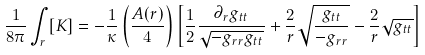Convert formula to latex. <formula><loc_0><loc_0><loc_500><loc_500>\frac { 1 } { 8 \pi } \int _ { r } { [ K ] } = - \frac { 1 } { \kappa } \left ( \frac { A ( r ) } { 4 } \right ) \left [ \frac { 1 } { 2 } \frac { \partial _ { r } g _ { t t } } { \sqrt { - g _ { r r } g _ { t t } } } + \frac { 2 } { r } \sqrt { \frac { g _ { t t } } { - g _ { r r } } } - \frac { 2 } { r } \sqrt { g _ { t t } } \right ]</formula> 